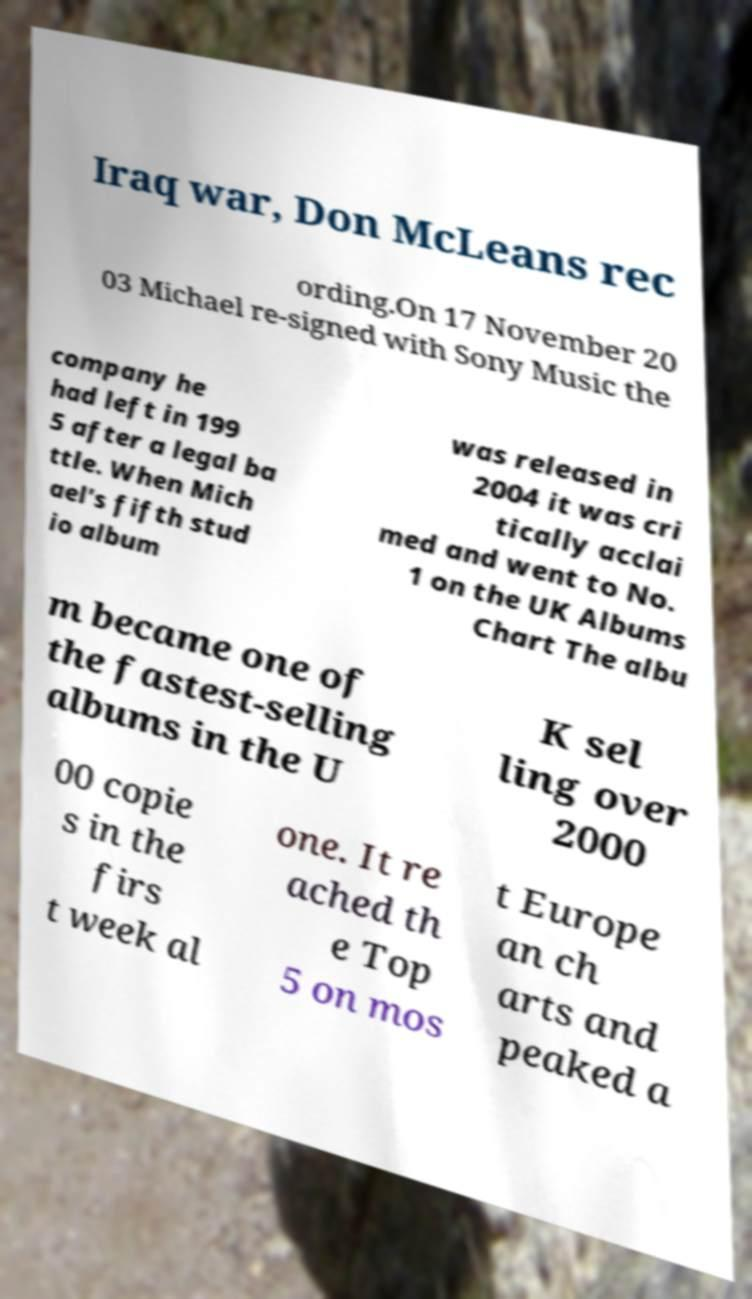Could you assist in decoding the text presented in this image and type it out clearly? Iraq war, Don McLeans rec ording.On 17 November 20 03 Michael re-signed with Sony Music the company he had left in 199 5 after a legal ba ttle. When Mich ael's fifth stud io album was released in 2004 it was cri tically acclai med and went to No. 1 on the UK Albums Chart The albu m became one of the fastest-selling albums in the U K sel ling over 2000 00 copie s in the firs t week al one. It re ached th e Top 5 on mos t Europe an ch arts and peaked a 